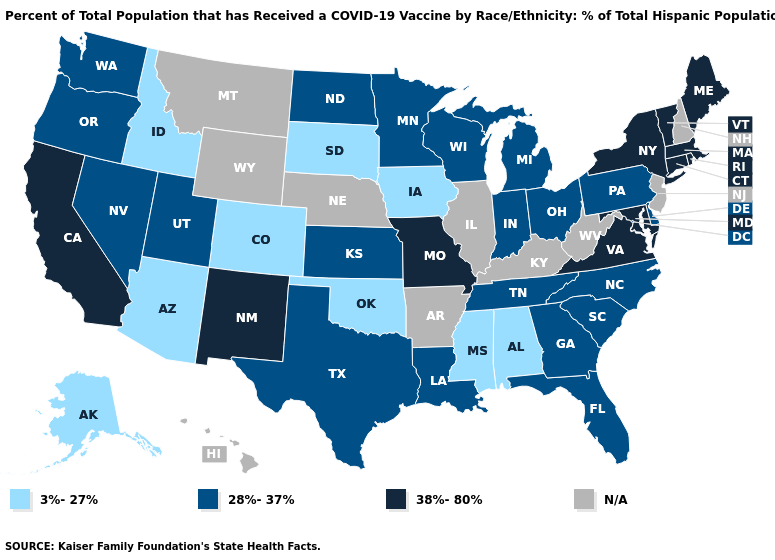What is the value of Hawaii?
Concise answer only. N/A. Name the states that have a value in the range 3%-27%?
Be succinct. Alabama, Alaska, Arizona, Colorado, Idaho, Iowa, Mississippi, Oklahoma, South Dakota. Among the states that border West Virginia , does Pennsylvania have the highest value?
Keep it brief. No. Name the states that have a value in the range 3%-27%?
Answer briefly. Alabama, Alaska, Arizona, Colorado, Idaho, Iowa, Mississippi, Oklahoma, South Dakota. Among the states that border New Mexico , which have the lowest value?
Give a very brief answer. Arizona, Colorado, Oklahoma. What is the value of Utah?
Concise answer only. 28%-37%. What is the highest value in states that border Wyoming?
Give a very brief answer. 28%-37%. What is the value of Wisconsin?
Keep it brief. 28%-37%. What is the highest value in the South ?
Answer briefly. 38%-80%. Among the states that border Minnesota , does Wisconsin have the lowest value?
Be succinct. No. What is the value of New Hampshire?
Give a very brief answer. N/A. Which states have the highest value in the USA?
Concise answer only. California, Connecticut, Maine, Maryland, Massachusetts, Missouri, New Mexico, New York, Rhode Island, Vermont, Virginia. What is the value of Delaware?
Give a very brief answer. 28%-37%. 